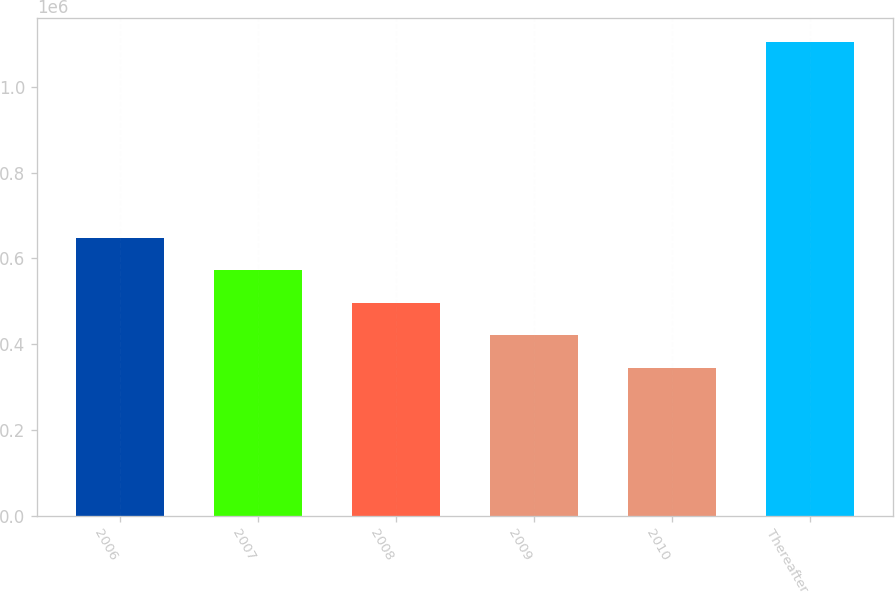Convert chart. <chart><loc_0><loc_0><loc_500><loc_500><bar_chart><fcel>2006<fcel>2007<fcel>2008<fcel>2009<fcel>2010<fcel>Thereafter<nl><fcel>648908<fcel>572792<fcel>496677<fcel>420562<fcel>344446<fcel>1.1056e+06<nl></chart> 